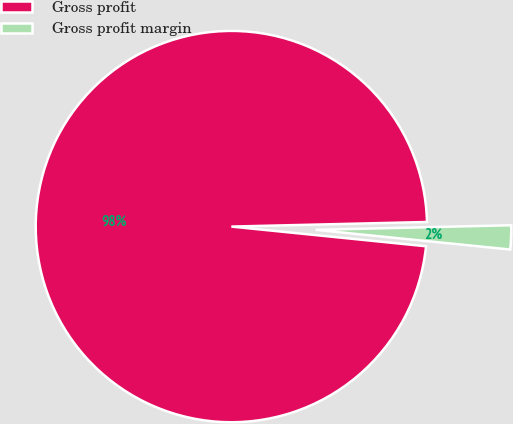Convert chart. <chart><loc_0><loc_0><loc_500><loc_500><pie_chart><fcel>Gross profit<fcel>Gross profit margin<nl><fcel>98.02%<fcel>1.98%<nl></chart> 